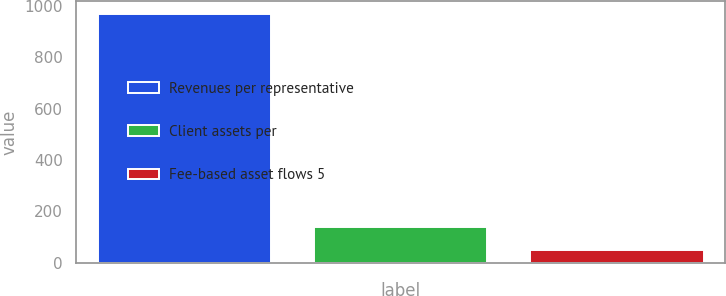Convert chart to OTSL. <chart><loc_0><loc_0><loc_500><loc_500><bar_chart><fcel>Revenues per representative<fcel>Client assets per<fcel>Fee-based asset flows 5<nl><fcel>968<fcel>140.45<fcel>48.5<nl></chart> 